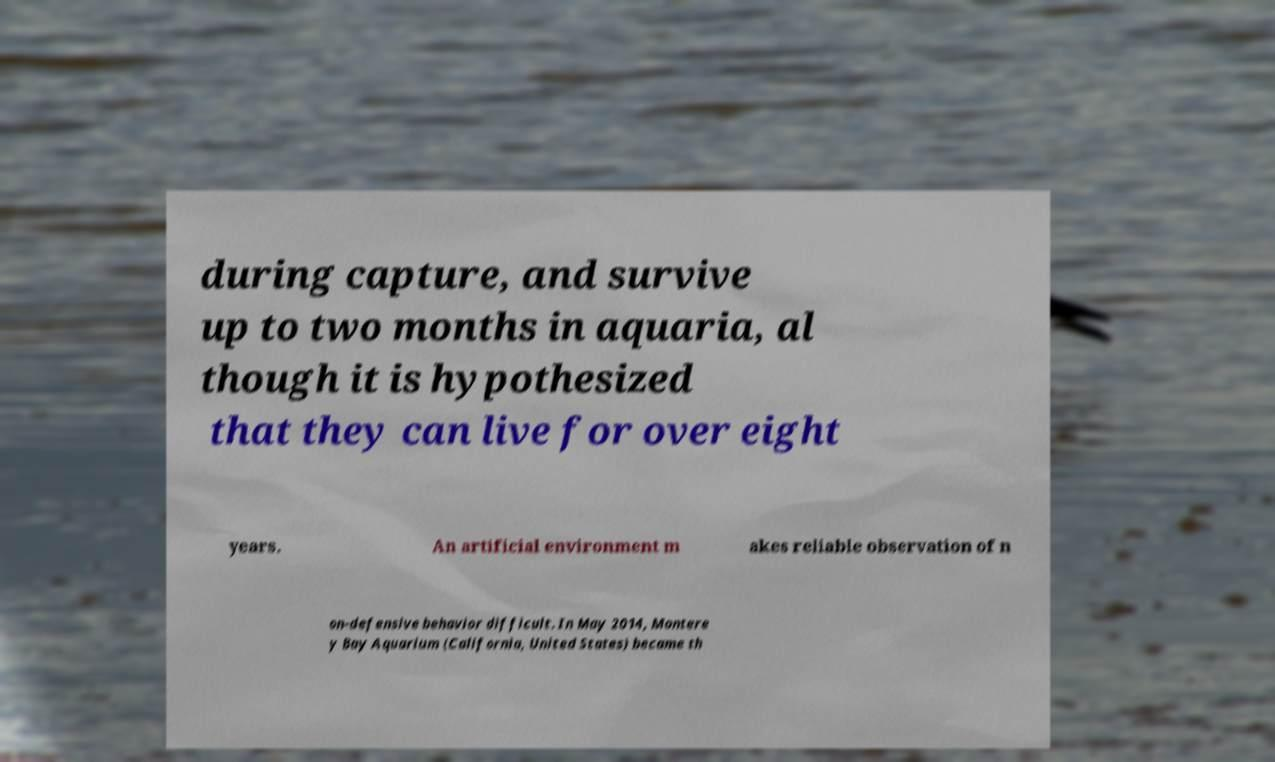Could you assist in decoding the text presented in this image and type it out clearly? during capture, and survive up to two months in aquaria, al though it is hypothesized that they can live for over eight years. An artificial environment m akes reliable observation of n on-defensive behavior difficult. In May 2014, Montere y Bay Aquarium (California, United States) became th 